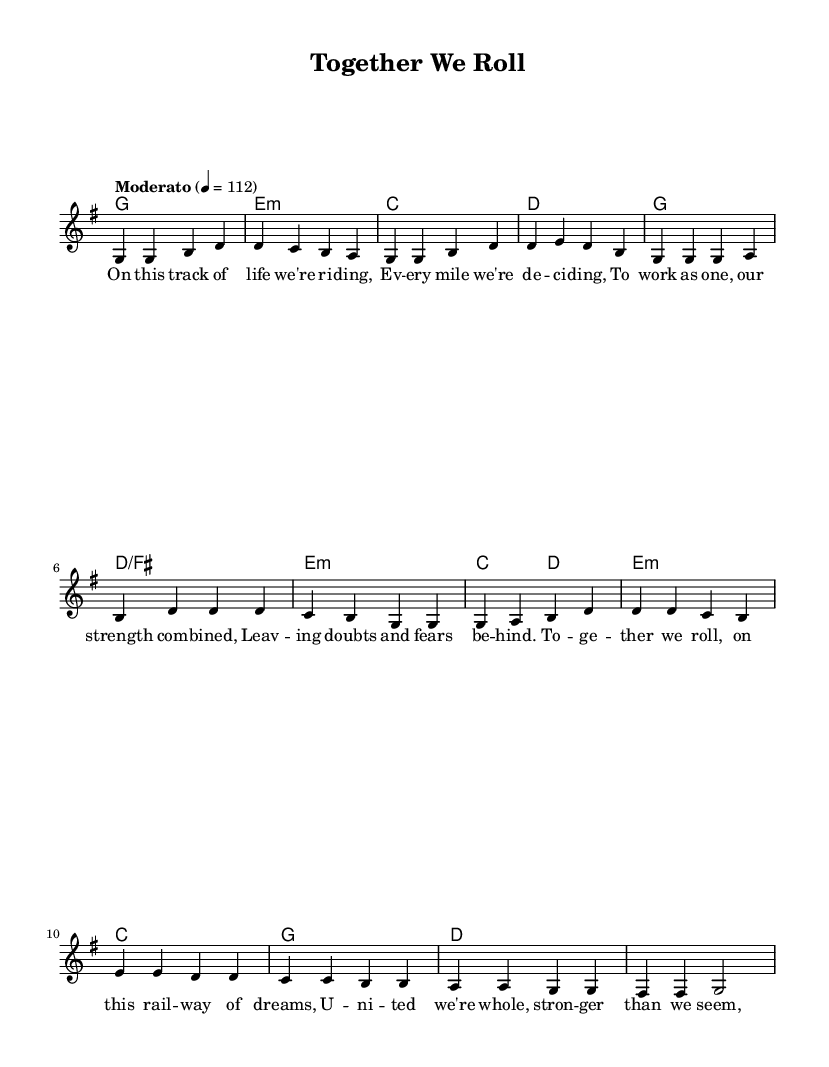What is the key signature of this music? The key signature is indicated by the sharp or flat symbols present at the beginning of the staff. In this case, there is one sharp (F#), which indicates G major.
Answer: G major What is the time signature of this music? The time signature is found at the beginning of the score, represented as a fraction. Here, the score shows 4 over 4, meaning four beats per measure.
Answer: 4/4 What is the tempo indication of this music? The tempo is indicated within the global block of the code as "Moderato" and a metronome mark of quarter note equals 112, suggesting a moderate speed.
Answer: Moderato, 112 How many verses are in the song? Each section labeled in the melody only includes one verse followed by the chorus, so it counts as a single verse.
Answer: 1 What is the main theme of the lyrics? The lyrics express a message of teamwork and unity, illustrating how working together leads to strength and fulfillment. This can be inferred from phrases such as "To together we roll."
Answer: Teamwork and unity What chords are played during the chorus? The chords for the chorus are indicated in the harmonies section, showing G, D/F#, E minor, and C. These chords support the lyrical structure during this part of the song.
Answer: G, D/F#, E minor, C Which part of the song contains a bridge? The bridge is a distinct section within the melody and harmonies, clearly marked after the chorus and features different chord progressions illustrating a shift in the song's structure.
Answer: After the chorus 